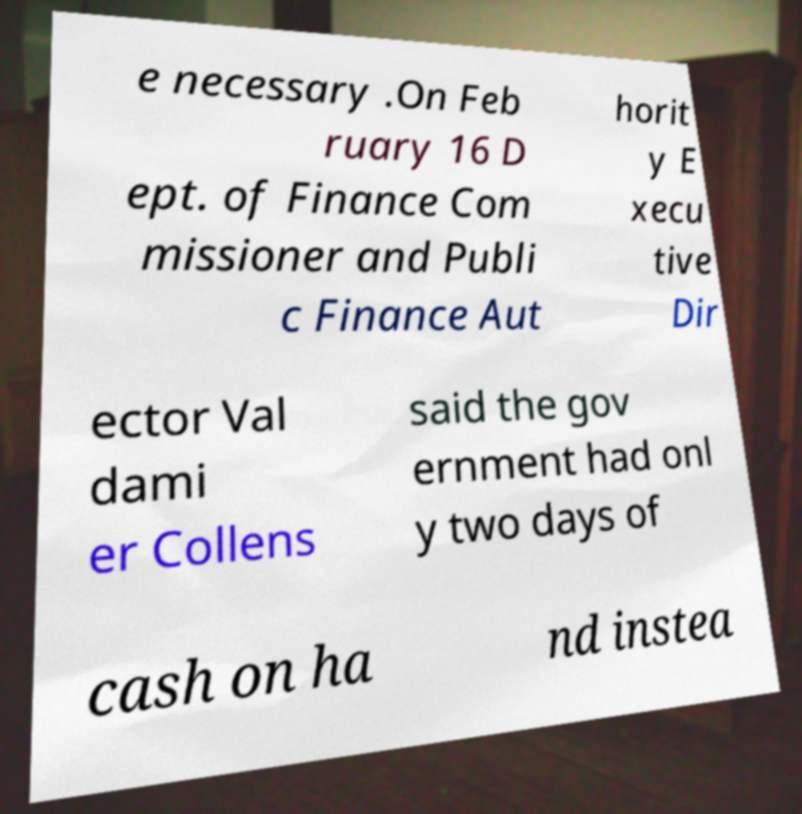Please read and relay the text visible in this image. What does it say? e necessary .On Feb ruary 16 D ept. of Finance Com missioner and Publi c Finance Aut horit y E xecu tive Dir ector Val dami er Collens said the gov ernment had onl y two days of cash on ha nd instea 